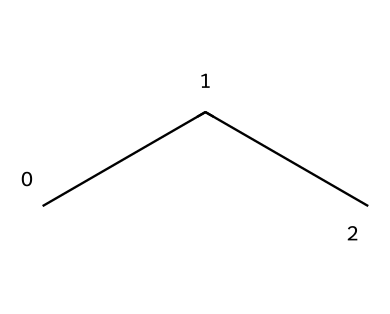What is the molecular formula of propane? Propane consists of three carbon atoms and eight hydrogen atoms connected to form its structure, represented by the SMILES notation CCC. The molecular formula is derived by counting the number of carbons (C) and hydrogens (H).
Answer: C3H8 How many carbon atoms are present in propane? By analyzing the chemical structure represented in the SMILES notation, we see three contiguous "C" characters, indicating three carbon atoms.
Answer: 3 What is the bond type between the atoms in propane? The connections between the carbon atoms and hydrogen atoms in propane are single bonds. This is inferred from the tetrahedral arrangement around the carbon and the stability of alkane hydrocarbons, which have only single bonds.
Answer: single Is propane a saturated or unsaturated hydrocarbon? Propane is classified as a saturated hydrocarbon because it contains only single bonds between carbon atoms, allowing it to bond with the maximum number of hydrogen atoms.
Answer: saturated What state is propane at room temperature? Propane is a gas at room temperature under normal atmospheric conditions, as is typical for alkanes with a low molecular weight like propane.
Answer: gas What type of bond predominates in the propane molecule? In propane, the predominant bond types are sigma (σ) bonds formed from the overlap of atomic orbitals, as alkanes do not feature multiple bonding.
Answer: sigma 